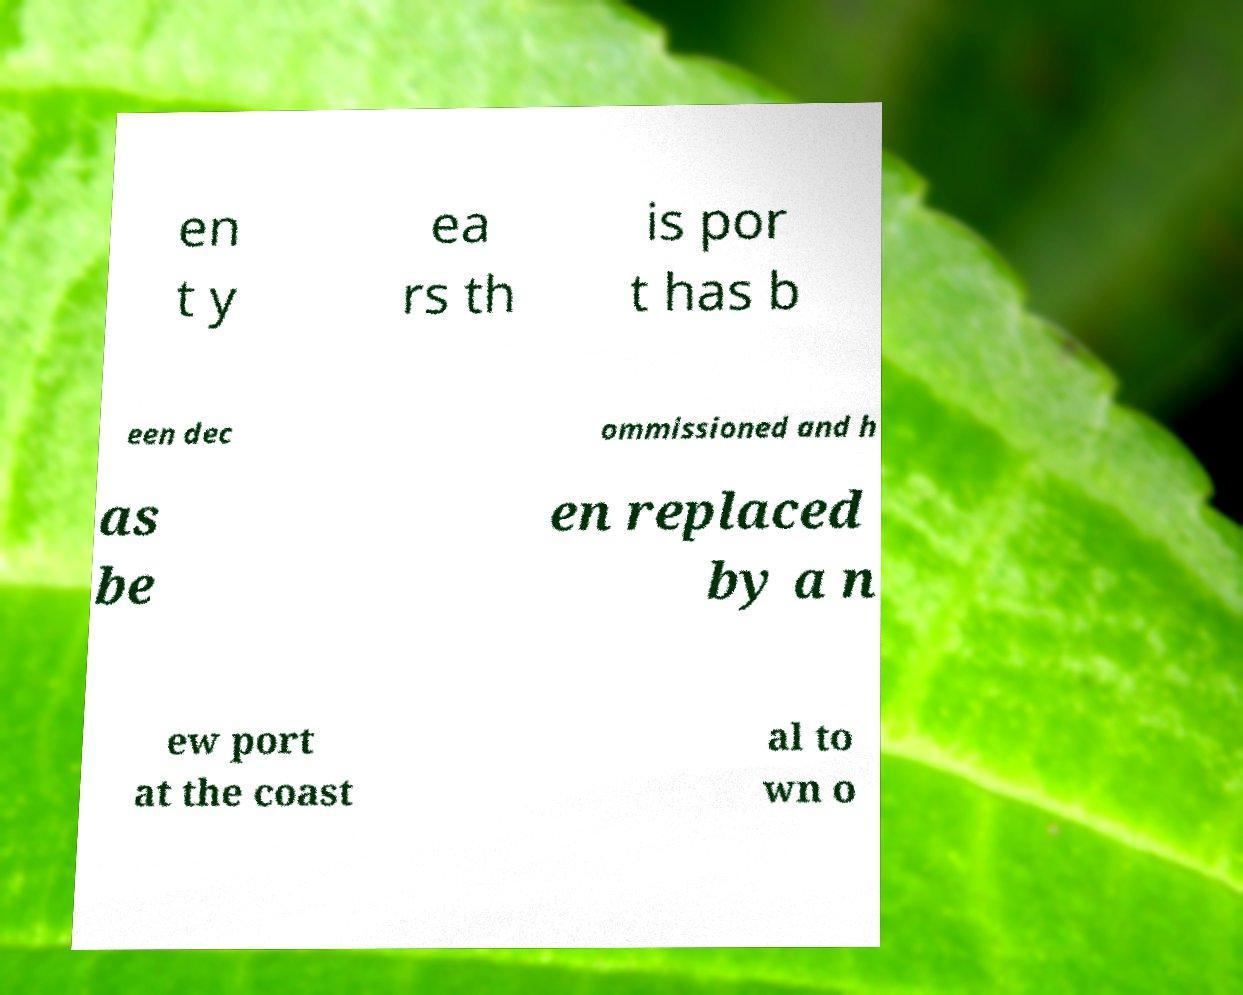For documentation purposes, I need the text within this image transcribed. Could you provide that? en t y ea rs th is por t has b een dec ommissioned and h as be en replaced by a n ew port at the coast al to wn o 